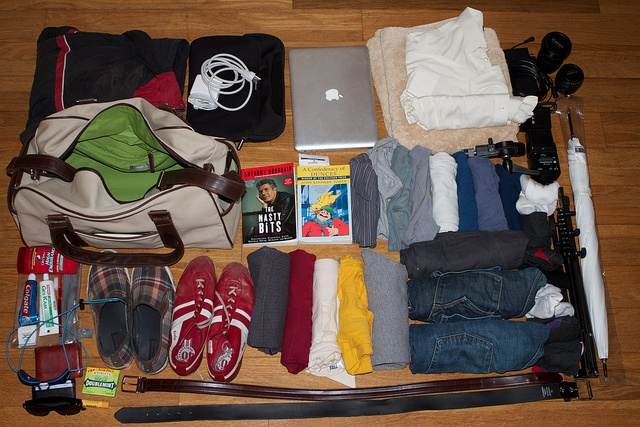Describe the objects in this image and their specific colors. I can see handbag in maroon, darkgray, black, darkgreen, and gray tones, laptop in maroon and gray tones, book in maroon, black, gray, red, and lightgray tones, book in maroon, gold, lightgray, lightblue, and red tones, and umbrella in maroon, lightgray, and darkgray tones in this image. 